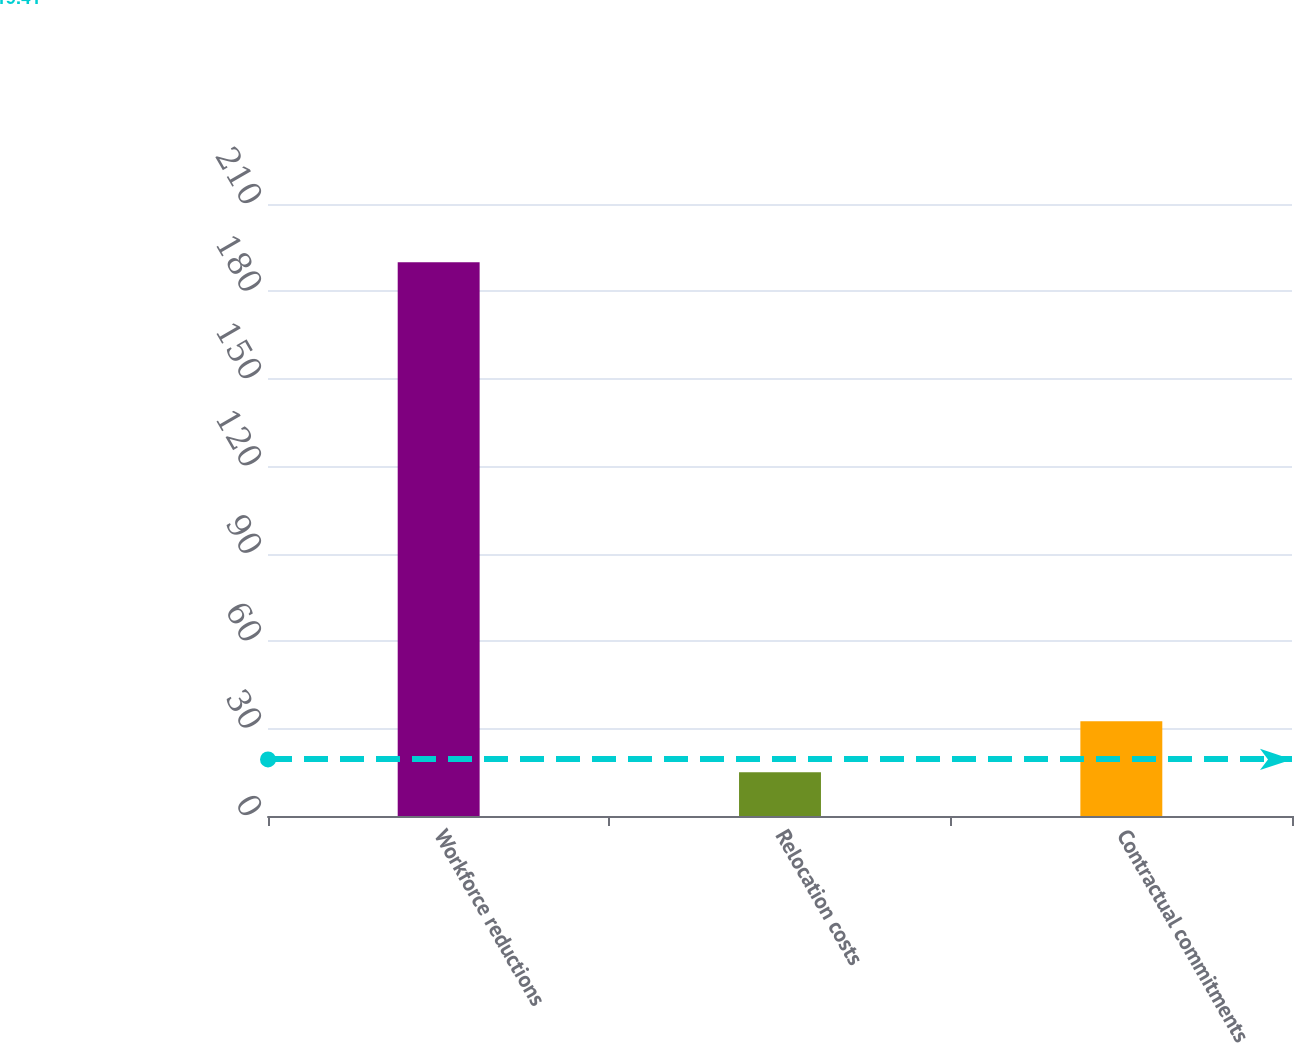Convert chart. <chart><loc_0><loc_0><loc_500><loc_500><bar_chart><fcel>Workforce reductions<fcel>Relocation costs<fcel>Contractual commitments<nl><fcel>190<fcel>15<fcel>32.5<nl></chart> 